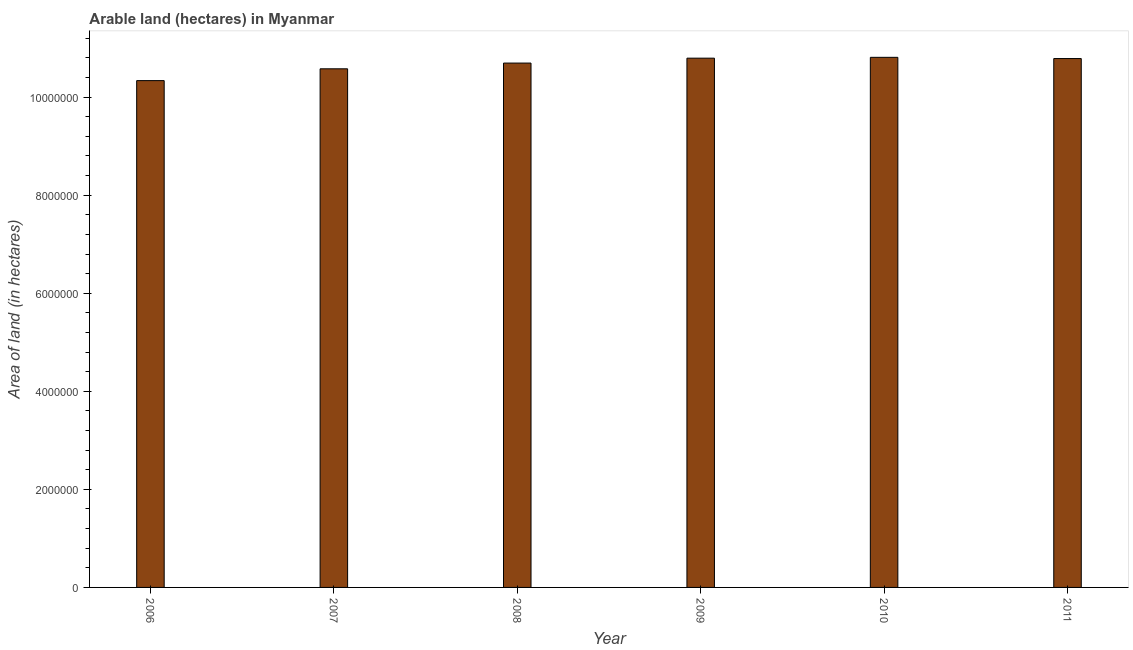Does the graph contain grids?
Keep it short and to the point. No. What is the title of the graph?
Your answer should be very brief. Arable land (hectares) in Myanmar. What is the label or title of the X-axis?
Offer a very short reply. Year. What is the label or title of the Y-axis?
Your response must be concise. Area of land (in hectares). What is the area of land in 2006?
Your response must be concise. 1.03e+07. Across all years, what is the maximum area of land?
Provide a short and direct response. 1.08e+07. Across all years, what is the minimum area of land?
Make the answer very short. 1.03e+07. In which year was the area of land maximum?
Provide a short and direct response. 2010. What is the sum of the area of land?
Give a very brief answer. 6.40e+07. What is the difference between the area of land in 2010 and 2011?
Offer a very short reply. 2.50e+04. What is the average area of land per year?
Provide a short and direct response. 1.07e+07. What is the median area of land?
Provide a succinct answer. 1.07e+07. In how many years, is the area of land greater than 2000000 hectares?
Provide a succinct answer. 6. Do a majority of the years between 2008 and 2010 (inclusive) have area of land greater than 3200000 hectares?
Keep it short and to the point. Yes. What is the ratio of the area of land in 2006 to that in 2010?
Your response must be concise. 0.96. What is the difference between the highest and the second highest area of land?
Your answer should be compact. 1.70e+04. Is the sum of the area of land in 2006 and 2009 greater than the maximum area of land across all years?
Give a very brief answer. Yes. What is the difference between the highest and the lowest area of land?
Keep it short and to the point. 4.75e+05. How many bars are there?
Make the answer very short. 6. Are all the bars in the graph horizontal?
Your response must be concise. No. Are the values on the major ticks of Y-axis written in scientific E-notation?
Make the answer very short. No. What is the Area of land (in hectares) of 2006?
Your response must be concise. 1.03e+07. What is the Area of land (in hectares) in 2007?
Your response must be concise. 1.06e+07. What is the Area of land (in hectares) in 2008?
Offer a very short reply. 1.07e+07. What is the Area of land (in hectares) of 2009?
Make the answer very short. 1.08e+07. What is the Area of land (in hectares) in 2010?
Provide a short and direct response. 1.08e+07. What is the Area of land (in hectares) of 2011?
Keep it short and to the point. 1.08e+07. What is the difference between the Area of land (in hectares) in 2006 and 2007?
Provide a succinct answer. -2.41e+05. What is the difference between the Area of land (in hectares) in 2006 and 2008?
Ensure brevity in your answer.  -3.58e+05. What is the difference between the Area of land (in hectares) in 2006 and 2009?
Offer a terse response. -4.58e+05. What is the difference between the Area of land (in hectares) in 2006 and 2010?
Your answer should be compact. -4.75e+05. What is the difference between the Area of land (in hectares) in 2006 and 2011?
Your answer should be compact. -4.50e+05. What is the difference between the Area of land (in hectares) in 2007 and 2008?
Make the answer very short. -1.17e+05. What is the difference between the Area of land (in hectares) in 2007 and 2009?
Your answer should be compact. -2.17e+05. What is the difference between the Area of land (in hectares) in 2007 and 2010?
Offer a terse response. -2.34e+05. What is the difference between the Area of land (in hectares) in 2007 and 2011?
Your answer should be compact. -2.09e+05. What is the difference between the Area of land (in hectares) in 2008 and 2009?
Keep it short and to the point. -1.00e+05. What is the difference between the Area of land (in hectares) in 2008 and 2010?
Provide a succinct answer. -1.17e+05. What is the difference between the Area of land (in hectares) in 2008 and 2011?
Make the answer very short. -9.20e+04. What is the difference between the Area of land (in hectares) in 2009 and 2010?
Your response must be concise. -1.70e+04. What is the difference between the Area of land (in hectares) in 2009 and 2011?
Keep it short and to the point. 8000. What is the difference between the Area of land (in hectares) in 2010 and 2011?
Offer a terse response. 2.50e+04. What is the ratio of the Area of land (in hectares) in 2006 to that in 2007?
Offer a very short reply. 0.98. What is the ratio of the Area of land (in hectares) in 2006 to that in 2008?
Provide a short and direct response. 0.97. What is the ratio of the Area of land (in hectares) in 2006 to that in 2009?
Make the answer very short. 0.96. What is the ratio of the Area of land (in hectares) in 2006 to that in 2010?
Offer a terse response. 0.96. What is the ratio of the Area of land (in hectares) in 2006 to that in 2011?
Ensure brevity in your answer.  0.96. What is the ratio of the Area of land (in hectares) in 2007 to that in 2008?
Make the answer very short. 0.99. What is the ratio of the Area of land (in hectares) in 2007 to that in 2009?
Keep it short and to the point. 0.98. What is the ratio of the Area of land (in hectares) in 2007 to that in 2010?
Your answer should be compact. 0.98. What is the ratio of the Area of land (in hectares) in 2007 to that in 2011?
Make the answer very short. 0.98. What is the ratio of the Area of land (in hectares) in 2008 to that in 2010?
Your answer should be compact. 0.99. What is the ratio of the Area of land (in hectares) in 2009 to that in 2010?
Give a very brief answer. 1. What is the ratio of the Area of land (in hectares) in 2009 to that in 2011?
Ensure brevity in your answer.  1. What is the ratio of the Area of land (in hectares) in 2010 to that in 2011?
Keep it short and to the point. 1. 